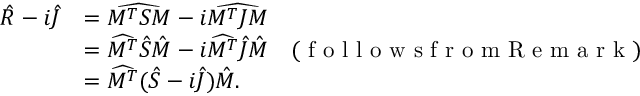<formula> <loc_0><loc_0><loc_500><loc_500>\begin{array} { r l } { \hat { R } - i \hat { J } } & { = \widehat { M ^ { T } S M } - i \widehat { M ^ { T } J M } } \\ & { = \widehat { M ^ { T } } \hat { S } \hat { M } - i \widehat { M ^ { T } } \hat { J } \hat { M } \quad ( f o l l o w s f r o m R e m a r k ) } \\ & { = \widehat { M ^ { T } } ( \hat { S } - i \hat { J } ) \hat { M } . } \end{array}</formula> 